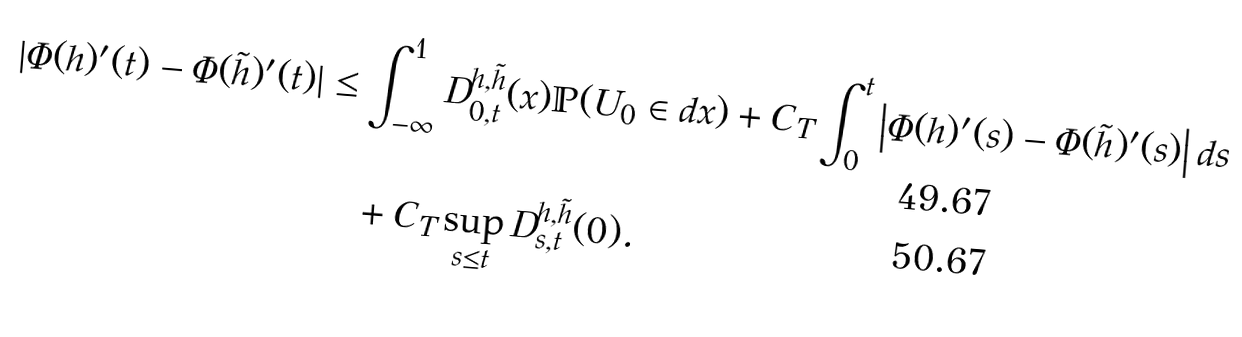<formula> <loc_0><loc_0><loc_500><loc_500>| \Phi ( h ) ^ { \prime } ( t ) - \Phi ( \tilde { h } ) ^ { \prime } ( t ) | & \leq \int _ { - \infty } ^ { 1 } D ^ { h , \tilde { h } } _ { 0 , t } ( x ) \mathbb { P } ( U _ { 0 } \in d x ) + C _ { T } \int _ { 0 } ^ { t } \left | \Phi ( h ) ^ { \prime } ( s ) - \Phi ( \tilde { h } ) ^ { \prime } ( s ) \right | d s \\ & \quad + C _ { T } \sup _ { s \leq t } D ^ { h , \tilde { h } } _ { s , t } ( 0 ) .</formula> 